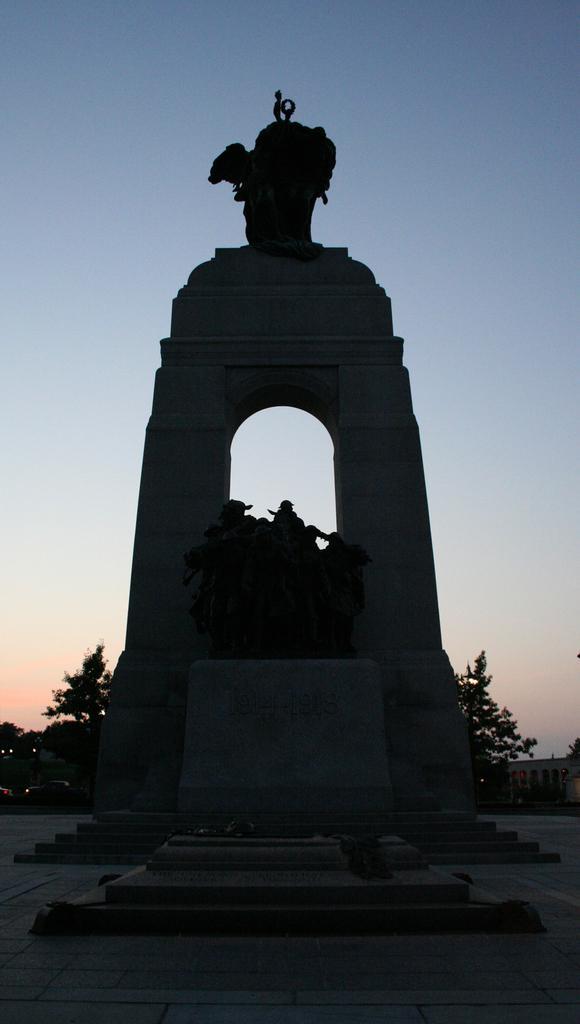Please provide a concise description of this image. In this image I can see the ground, black colored statue and a concrete structure behind it. In the background I can see few trees, a car, a building and the sky. 